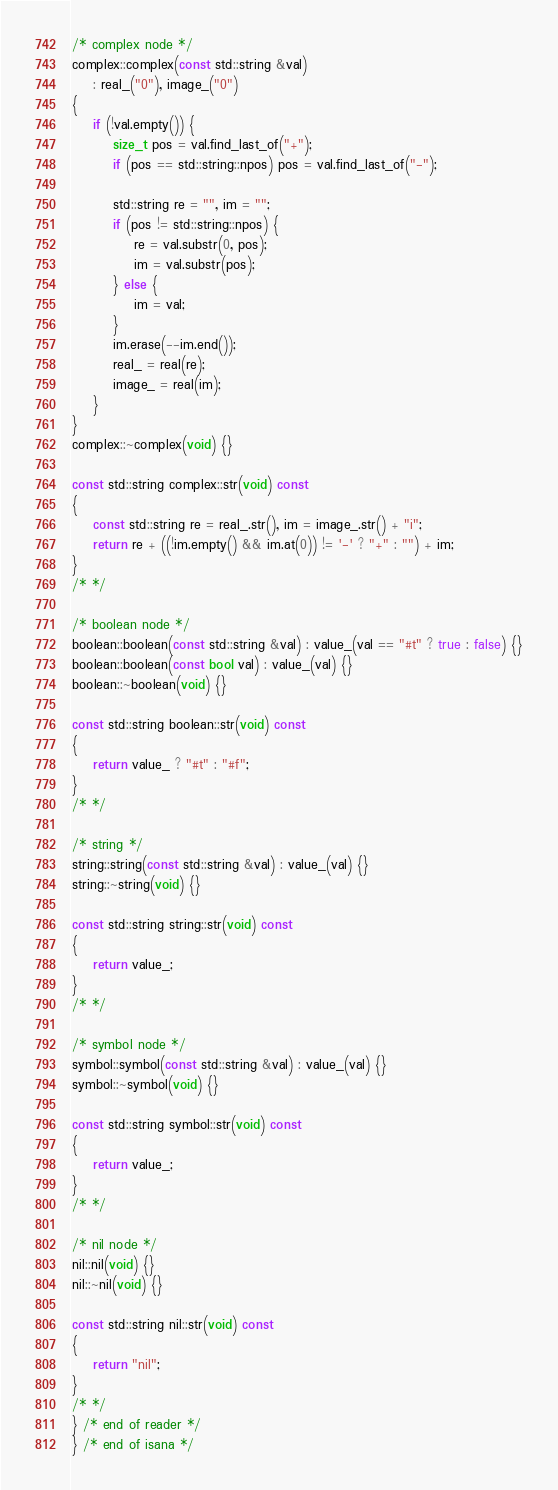Convert code to text. <code><loc_0><loc_0><loc_500><loc_500><_C++_>/* complex node */
complex::complex(const std::string &val)
    : real_("0"), image_("0")
{
    if (!val.empty()) {
        size_t pos = val.find_last_of("+");
        if (pos == std::string::npos) pos = val.find_last_of("-");

        std::string re = "", im = "";
        if (pos != std::string::npos) {
            re = val.substr(0, pos);
            im = val.substr(pos);
        } else {
            im = val;
        }
        im.erase(--im.end());
        real_ = real(re);
        image_ = real(im);
    }
}
complex::~complex(void) {}

const std::string complex::str(void) const
{
    const std::string re = real_.str(), im = image_.str() + "i";
    return re + ((!im.empty() && im.at(0)) != '-' ? "+" : "") + im;
}
/* */

/* boolean node */
boolean::boolean(const std::string &val) : value_(val == "#t" ? true : false) {}
boolean::boolean(const bool val) : value_(val) {}
boolean::~boolean(void) {}

const std::string boolean::str(void) const
{
    return value_ ? "#t" : "#f";
}
/* */

/* string */
string::string(const std::string &val) : value_(val) {}
string::~string(void) {}

const std::string string::str(void) const
{
    return value_;
}
/* */

/* symbol node */
symbol::symbol(const std::string &val) : value_(val) {}
symbol::~symbol(void) {}

const std::string symbol::str(void) const
{
    return value_;
}
/* */

/* nil node */
nil::nil(void) {}
nil::~nil(void) {}

const std::string nil::str(void) const
{
    return "nil";
}
/* */
} /* end of reader */
} /* end of isana */
</code> 